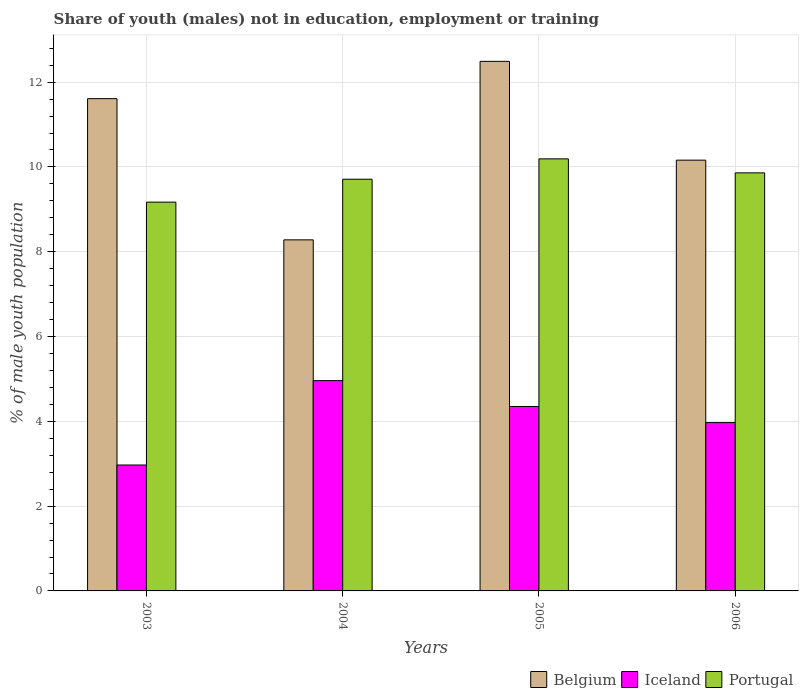How many different coloured bars are there?
Give a very brief answer. 3. How many bars are there on the 2nd tick from the left?
Ensure brevity in your answer.  3. What is the label of the 4th group of bars from the left?
Ensure brevity in your answer.  2006. What is the percentage of unemployed males population in in Portugal in 2006?
Keep it short and to the point. 9.86. Across all years, what is the maximum percentage of unemployed males population in in Iceland?
Ensure brevity in your answer.  4.96. Across all years, what is the minimum percentage of unemployed males population in in Iceland?
Provide a succinct answer. 2.97. What is the total percentage of unemployed males population in in Portugal in the graph?
Your answer should be compact. 38.93. What is the difference between the percentage of unemployed males population in in Iceland in 2005 and that in 2006?
Your response must be concise. 0.38. What is the difference between the percentage of unemployed males population in in Portugal in 2005 and the percentage of unemployed males population in in Iceland in 2006?
Make the answer very short. 6.22. What is the average percentage of unemployed males population in in Iceland per year?
Provide a short and direct response. 4.06. In the year 2005, what is the difference between the percentage of unemployed males population in in Belgium and percentage of unemployed males population in in Portugal?
Provide a succinct answer. 2.3. In how many years, is the percentage of unemployed males population in in Portugal greater than 10.8 %?
Give a very brief answer. 0. What is the ratio of the percentage of unemployed males population in in Iceland in 2003 to that in 2004?
Offer a terse response. 0.6. What is the difference between the highest and the second highest percentage of unemployed males population in in Belgium?
Your response must be concise. 0.88. What is the difference between the highest and the lowest percentage of unemployed males population in in Iceland?
Offer a very short reply. 1.99. Is the sum of the percentage of unemployed males population in in Belgium in 2005 and 2006 greater than the maximum percentage of unemployed males population in in Iceland across all years?
Give a very brief answer. Yes. What does the 1st bar from the left in 2005 represents?
Ensure brevity in your answer.  Belgium. What does the 3rd bar from the right in 2005 represents?
Keep it short and to the point. Belgium. Is it the case that in every year, the sum of the percentage of unemployed males population in in Iceland and percentage of unemployed males population in in Portugal is greater than the percentage of unemployed males population in in Belgium?
Your answer should be very brief. Yes. Are all the bars in the graph horizontal?
Make the answer very short. No. How many years are there in the graph?
Make the answer very short. 4. What is the difference between two consecutive major ticks on the Y-axis?
Ensure brevity in your answer.  2. Are the values on the major ticks of Y-axis written in scientific E-notation?
Keep it short and to the point. No. Does the graph contain any zero values?
Provide a succinct answer. No. Where does the legend appear in the graph?
Make the answer very short. Bottom right. How many legend labels are there?
Make the answer very short. 3. How are the legend labels stacked?
Provide a short and direct response. Horizontal. What is the title of the graph?
Keep it short and to the point. Share of youth (males) not in education, employment or training. Does "Burkina Faso" appear as one of the legend labels in the graph?
Ensure brevity in your answer.  No. What is the label or title of the X-axis?
Offer a terse response. Years. What is the label or title of the Y-axis?
Give a very brief answer. % of male youth population. What is the % of male youth population of Belgium in 2003?
Provide a succinct answer. 11.61. What is the % of male youth population in Iceland in 2003?
Ensure brevity in your answer.  2.97. What is the % of male youth population in Portugal in 2003?
Provide a succinct answer. 9.17. What is the % of male youth population of Belgium in 2004?
Ensure brevity in your answer.  8.28. What is the % of male youth population in Iceland in 2004?
Ensure brevity in your answer.  4.96. What is the % of male youth population of Portugal in 2004?
Provide a succinct answer. 9.71. What is the % of male youth population in Belgium in 2005?
Your response must be concise. 12.49. What is the % of male youth population in Iceland in 2005?
Ensure brevity in your answer.  4.35. What is the % of male youth population of Portugal in 2005?
Provide a short and direct response. 10.19. What is the % of male youth population of Belgium in 2006?
Provide a succinct answer. 10.16. What is the % of male youth population of Iceland in 2006?
Keep it short and to the point. 3.97. What is the % of male youth population in Portugal in 2006?
Keep it short and to the point. 9.86. Across all years, what is the maximum % of male youth population of Belgium?
Your answer should be compact. 12.49. Across all years, what is the maximum % of male youth population in Iceland?
Your response must be concise. 4.96. Across all years, what is the maximum % of male youth population in Portugal?
Provide a succinct answer. 10.19. Across all years, what is the minimum % of male youth population of Belgium?
Give a very brief answer. 8.28. Across all years, what is the minimum % of male youth population in Iceland?
Provide a short and direct response. 2.97. Across all years, what is the minimum % of male youth population of Portugal?
Your response must be concise. 9.17. What is the total % of male youth population in Belgium in the graph?
Offer a terse response. 42.54. What is the total % of male youth population in Iceland in the graph?
Offer a very short reply. 16.25. What is the total % of male youth population of Portugal in the graph?
Keep it short and to the point. 38.93. What is the difference between the % of male youth population in Belgium in 2003 and that in 2004?
Give a very brief answer. 3.33. What is the difference between the % of male youth population of Iceland in 2003 and that in 2004?
Provide a succinct answer. -1.99. What is the difference between the % of male youth population of Portugal in 2003 and that in 2004?
Provide a succinct answer. -0.54. What is the difference between the % of male youth population of Belgium in 2003 and that in 2005?
Your answer should be very brief. -0.88. What is the difference between the % of male youth population of Iceland in 2003 and that in 2005?
Your answer should be very brief. -1.38. What is the difference between the % of male youth population of Portugal in 2003 and that in 2005?
Your answer should be compact. -1.02. What is the difference between the % of male youth population in Belgium in 2003 and that in 2006?
Keep it short and to the point. 1.45. What is the difference between the % of male youth population in Portugal in 2003 and that in 2006?
Provide a succinct answer. -0.69. What is the difference between the % of male youth population in Belgium in 2004 and that in 2005?
Offer a very short reply. -4.21. What is the difference between the % of male youth population in Iceland in 2004 and that in 2005?
Ensure brevity in your answer.  0.61. What is the difference between the % of male youth population of Portugal in 2004 and that in 2005?
Give a very brief answer. -0.48. What is the difference between the % of male youth population of Belgium in 2004 and that in 2006?
Your answer should be compact. -1.88. What is the difference between the % of male youth population of Portugal in 2004 and that in 2006?
Give a very brief answer. -0.15. What is the difference between the % of male youth population of Belgium in 2005 and that in 2006?
Provide a succinct answer. 2.33. What is the difference between the % of male youth population in Iceland in 2005 and that in 2006?
Your answer should be compact. 0.38. What is the difference between the % of male youth population in Portugal in 2005 and that in 2006?
Make the answer very short. 0.33. What is the difference between the % of male youth population of Belgium in 2003 and the % of male youth population of Iceland in 2004?
Provide a short and direct response. 6.65. What is the difference between the % of male youth population in Belgium in 2003 and the % of male youth population in Portugal in 2004?
Provide a short and direct response. 1.9. What is the difference between the % of male youth population in Iceland in 2003 and the % of male youth population in Portugal in 2004?
Your response must be concise. -6.74. What is the difference between the % of male youth population of Belgium in 2003 and the % of male youth population of Iceland in 2005?
Offer a terse response. 7.26. What is the difference between the % of male youth population in Belgium in 2003 and the % of male youth population in Portugal in 2005?
Offer a terse response. 1.42. What is the difference between the % of male youth population of Iceland in 2003 and the % of male youth population of Portugal in 2005?
Your answer should be very brief. -7.22. What is the difference between the % of male youth population in Belgium in 2003 and the % of male youth population in Iceland in 2006?
Give a very brief answer. 7.64. What is the difference between the % of male youth population in Belgium in 2003 and the % of male youth population in Portugal in 2006?
Keep it short and to the point. 1.75. What is the difference between the % of male youth population of Iceland in 2003 and the % of male youth population of Portugal in 2006?
Ensure brevity in your answer.  -6.89. What is the difference between the % of male youth population in Belgium in 2004 and the % of male youth population in Iceland in 2005?
Give a very brief answer. 3.93. What is the difference between the % of male youth population in Belgium in 2004 and the % of male youth population in Portugal in 2005?
Your answer should be very brief. -1.91. What is the difference between the % of male youth population of Iceland in 2004 and the % of male youth population of Portugal in 2005?
Give a very brief answer. -5.23. What is the difference between the % of male youth population in Belgium in 2004 and the % of male youth population in Iceland in 2006?
Give a very brief answer. 4.31. What is the difference between the % of male youth population in Belgium in 2004 and the % of male youth population in Portugal in 2006?
Offer a very short reply. -1.58. What is the difference between the % of male youth population of Iceland in 2004 and the % of male youth population of Portugal in 2006?
Your answer should be very brief. -4.9. What is the difference between the % of male youth population in Belgium in 2005 and the % of male youth population in Iceland in 2006?
Your response must be concise. 8.52. What is the difference between the % of male youth population of Belgium in 2005 and the % of male youth population of Portugal in 2006?
Your answer should be very brief. 2.63. What is the difference between the % of male youth population of Iceland in 2005 and the % of male youth population of Portugal in 2006?
Your answer should be very brief. -5.51. What is the average % of male youth population in Belgium per year?
Offer a terse response. 10.63. What is the average % of male youth population of Iceland per year?
Your answer should be very brief. 4.06. What is the average % of male youth population in Portugal per year?
Your answer should be compact. 9.73. In the year 2003, what is the difference between the % of male youth population in Belgium and % of male youth population in Iceland?
Your response must be concise. 8.64. In the year 2003, what is the difference between the % of male youth population in Belgium and % of male youth population in Portugal?
Your answer should be compact. 2.44. In the year 2004, what is the difference between the % of male youth population of Belgium and % of male youth population of Iceland?
Provide a succinct answer. 3.32. In the year 2004, what is the difference between the % of male youth population of Belgium and % of male youth population of Portugal?
Provide a short and direct response. -1.43. In the year 2004, what is the difference between the % of male youth population in Iceland and % of male youth population in Portugal?
Your answer should be compact. -4.75. In the year 2005, what is the difference between the % of male youth population in Belgium and % of male youth population in Iceland?
Give a very brief answer. 8.14. In the year 2005, what is the difference between the % of male youth population of Iceland and % of male youth population of Portugal?
Ensure brevity in your answer.  -5.84. In the year 2006, what is the difference between the % of male youth population in Belgium and % of male youth population in Iceland?
Your response must be concise. 6.19. In the year 2006, what is the difference between the % of male youth population in Belgium and % of male youth population in Portugal?
Your answer should be very brief. 0.3. In the year 2006, what is the difference between the % of male youth population of Iceland and % of male youth population of Portugal?
Offer a very short reply. -5.89. What is the ratio of the % of male youth population of Belgium in 2003 to that in 2004?
Offer a terse response. 1.4. What is the ratio of the % of male youth population in Iceland in 2003 to that in 2004?
Ensure brevity in your answer.  0.6. What is the ratio of the % of male youth population of Belgium in 2003 to that in 2005?
Provide a short and direct response. 0.93. What is the ratio of the % of male youth population of Iceland in 2003 to that in 2005?
Offer a terse response. 0.68. What is the ratio of the % of male youth population in Portugal in 2003 to that in 2005?
Ensure brevity in your answer.  0.9. What is the ratio of the % of male youth population in Belgium in 2003 to that in 2006?
Provide a succinct answer. 1.14. What is the ratio of the % of male youth population in Iceland in 2003 to that in 2006?
Your answer should be compact. 0.75. What is the ratio of the % of male youth population of Belgium in 2004 to that in 2005?
Make the answer very short. 0.66. What is the ratio of the % of male youth population of Iceland in 2004 to that in 2005?
Your answer should be very brief. 1.14. What is the ratio of the % of male youth population in Portugal in 2004 to that in 2005?
Provide a short and direct response. 0.95. What is the ratio of the % of male youth population in Belgium in 2004 to that in 2006?
Keep it short and to the point. 0.81. What is the ratio of the % of male youth population in Iceland in 2004 to that in 2006?
Your answer should be compact. 1.25. What is the ratio of the % of male youth population in Belgium in 2005 to that in 2006?
Offer a very short reply. 1.23. What is the ratio of the % of male youth population in Iceland in 2005 to that in 2006?
Provide a succinct answer. 1.1. What is the ratio of the % of male youth population of Portugal in 2005 to that in 2006?
Your answer should be very brief. 1.03. What is the difference between the highest and the second highest % of male youth population of Belgium?
Give a very brief answer. 0.88. What is the difference between the highest and the second highest % of male youth population of Iceland?
Your answer should be very brief. 0.61. What is the difference between the highest and the second highest % of male youth population in Portugal?
Keep it short and to the point. 0.33. What is the difference between the highest and the lowest % of male youth population in Belgium?
Provide a short and direct response. 4.21. What is the difference between the highest and the lowest % of male youth population in Iceland?
Your response must be concise. 1.99. 